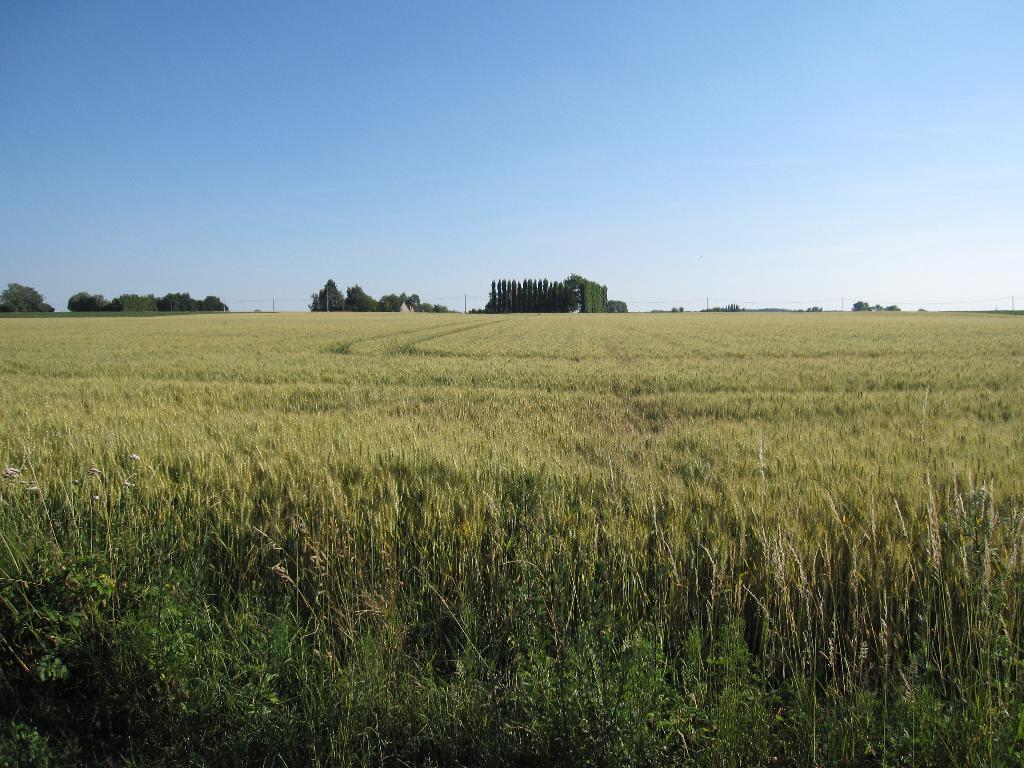Can you describe this image briefly? In the picture we can see a crop with full of grass plants and far away from it we can see trees, poles and sky. 